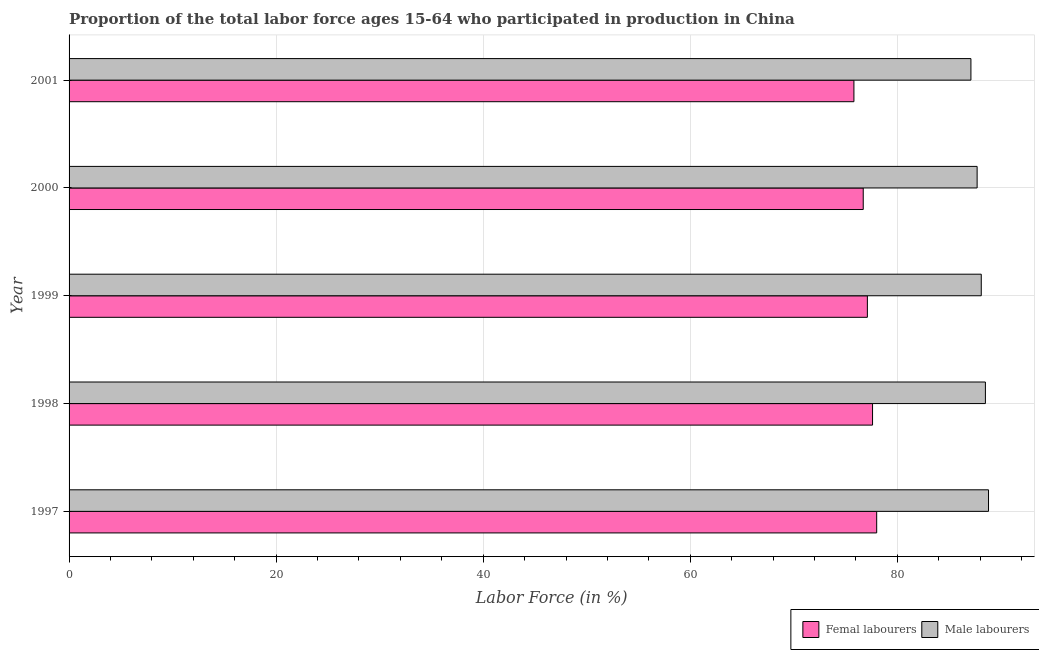How many different coloured bars are there?
Provide a succinct answer. 2. How many bars are there on the 4th tick from the bottom?
Ensure brevity in your answer.  2. What is the label of the 3rd group of bars from the top?
Your answer should be very brief. 1999. What is the percentage of male labour force in 1998?
Your answer should be compact. 88.5. Across all years, what is the maximum percentage of female labor force?
Your answer should be very brief. 78. Across all years, what is the minimum percentage of male labour force?
Your answer should be compact. 87.1. In which year was the percentage of female labor force maximum?
Your answer should be compact. 1997. In which year was the percentage of female labor force minimum?
Give a very brief answer. 2001. What is the total percentage of male labour force in the graph?
Offer a very short reply. 440.2. What is the difference between the percentage of male labour force in 1999 and that in 2000?
Keep it short and to the point. 0.4. What is the difference between the percentage of female labor force in 1999 and the percentage of male labour force in 1997?
Keep it short and to the point. -11.7. What is the average percentage of female labor force per year?
Give a very brief answer. 77.04. In the year 2000, what is the difference between the percentage of male labour force and percentage of female labor force?
Ensure brevity in your answer.  11. In how many years, is the percentage of male labour force greater than 84 %?
Ensure brevity in your answer.  5. What is the ratio of the percentage of female labor force in 1998 to that in 1999?
Provide a short and direct response. 1.01. Is the percentage of female labor force in 1999 less than that in 2001?
Give a very brief answer. No. Is the difference between the percentage of female labor force in 1997 and 1998 greater than the difference between the percentage of male labour force in 1997 and 1998?
Ensure brevity in your answer.  Yes. What is the difference between the highest and the second highest percentage of female labor force?
Provide a succinct answer. 0.4. What is the difference between the highest and the lowest percentage of male labour force?
Offer a very short reply. 1.7. In how many years, is the percentage of female labor force greater than the average percentage of female labor force taken over all years?
Keep it short and to the point. 3. What does the 2nd bar from the top in 1999 represents?
Provide a succinct answer. Femal labourers. What does the 1st bar from the bottom in 1998 represents?
Make the answer very short. Femal labourers. Are all the bars in the graph horizontal?
Offer a very short reply. Yes. Are the values on the major ticks of X-axis written in scientific E-notation?
Offer a very short reply. No. Does the graph contain any zero values?
Ensure brevity in your answer.  No. Where does the legend appear in the graph?
Offer a terse response. Bottom right. How are the legend labels stacked?
Keep it short and to the point. Horizontal. What is the title of the graph?
Ensure brevity in your answer.  Proportion of the total labor force ages 15-64 who participated in production in China. What is the label or title of the Y-axis?
Your answer should be very brief. Year. What is the Labor Force (in %) of Femal labourers in 1997?
Give a very brief answer. 78. What is the Labor Force (in %) of Male labourers in 1997?
Keep it short and to the point. 88.8. What is the Labor Force (in %) in Femal labourers in 1998?
Give a very brief answer. 77.6. What is the Labor Force (in %) in Male labourers in 1998?
Keep it short and to the point. 88.5. What is the Labor Force (in %) in Femal labourers in 1999?
Provide a succinct answer. 77.1. What is the Labor Force (in %) in Male labourers in 1999?
Ensure brevity in your answer.  88.1. What is the Labor Force (in %) of Femal labourers in 2000?
Offer a terse response. 76.7. What is the Labor Force (in %) in Male labourers in 2000?
Offer a very short reply. 87.7. What is the Labor Force (in %) in Femal labourers in 2001?
Ensure brevity in your answer.  75.8. What is the Labor Force (in %) of Male labourers in 2001?
Make the answer very short. 87.1. Across all years, what is the maximum Labor Force (in %) in Male labourers?
Provide a short and direct response. 88.8. Across all years, what is the minimum Labor Force (in %) in Femal labourers?
Your answer should be very brief. 75.8. Across all years, what is the minimum Labor Force (in %) of Male labourers?
Provide a succinct answer. 87.1. What is the total Labor Force (in %) in Femal labourers in the graph?
Your answer should be very brief. 385.2. What is the total Labor Force (in %) of Male labourers in the graph?
Your answer should be compact. 440.2. What is the difference between the Labor Force (in %) in Femal labourers in 1997 and that in 1999?
Provide a short and direct response. 0.9. What is the difference between the Labor Force (in %) in Male labourers in 1997 and that in 2000?
Ensure brevity in your answer.  1.1. What is the difference between the Labor Force (in %) in Femal labourers in 1997 and that in 2001?
Keep it short and to the point. 2.2. What is the difference between the Labor Force (in %) in Femal labourers in 1998 and that in 1999?
Keep it short and to the point. 0.5. What is the difference between the Labor Force (in %) in Male labourers in 1998 and that in 1999?
Offer a terse response. 0.4. What is the difference between the Labor Force (in %) of Femal labourers in 1998 and that in 2000?
Ensure brevity in your answer.  0.9. What is the difference between the Labor Force (in %) in Male labourers in 1998 and that in 2000?
Offer a very short reply. 0.8. What is the difference between the Labor Force (in %) of Male labourers in 1998 and that in 2001?
Keep it short and to the point. 1.4. What is the difference between the Labor Force (in %) of Femal labourers in 1999 and that in 2000?
Your answer should be compact. 0.4. What is the difference between the Labor Force (in %) in Male labourers in 1999 and that in 2000?
Your response must be concise. 0.4. What is the difference between the Labor Force (in %) of Femal labourers in 2000 and that in 2001?
Ensure brevity in your answer.  0.9. What is the difference between the Labor Force (in %) in Femal labourers in 1997 and the Labor Force (in %) in Male labourers in 2000?
Offer a terse response. -9.7. What is the difference between the Labor Force (in %) in Femal labourers in 1998 and the Labor Force (in %) in Male labourers in 1999?
Keep it short and to the point. -10.5. What is the difference between the Labor Force (in %) of Femal labourers in 1998 and the Labor Force (in %) of Male labourers in 2001?
Provide a succinct answer. -9.5. What is the difference between the Labor Force (in %) of Femal labourers in 1999 and the Labor Force (in %) of Male labourers in 2000?
Your answer should be compact. -10.6. What is the difference between the Labor Force (in %) in Femal labourers in 1999 and the Labor Force (in %) in Male labourers in 2001?
Keep it short and to the point. -10. What is the average Labor Force (in %) in Femal labourers per year?
Your answer should be very brief. 77.04. What is the average Labor Force (in %) in Male labourers per year?
Provide a succinct answer. 88.04. In the year 1998, what is the difference between the Labor Force (in %) of Femal labourers and Labor Force (in %) of Male labourers?
Your answer should be compact. -10.9. In the year 2001, what is the difference between the Labor Force (in %) in Femal labourers and Labor Force (in %) in Male labourers?
Provide a short and direct response. -11.3. What is the ratio of the Labor Force (in %) of Male labourers in 1997 to that in 1998?
Offer a terse response. 1. What is the ratio of the Labor Force (in %) of Femal labourers in 1997 to that in 1999?
Your answer should be very brief. 1.01. What is the ratio of the Labor Force (in %) in Male labourers in 1997 to that in 1999?
Your answer should be very brief. 1.01. What is the ratio of the Labor Force (in %) in Femal labourers in 1997 to that in 2000?
Give a very brief answer. 1.02. What is the ratio of the Labor Force (in %) of Male labourers in 1997 to that in 2000?
Keep it short and to the point. 1.01. What is the ratio of the Labor Force (in %) in Femal labourers in 1997 to that in 2001?
Your answer should be very brief. 1.03. What is the ratio of the Labor Force (in %) of Male labourers in 1997 to that in 2001?
Give a very brief answer. 1.02. What is the ratio of the Labor Force (in %) of Femal labourers in 1998 to that in 1999?
Your answer should be very brief. 1.01. What is the ratio of the Labor Force (in %) of Femal labourers in 1998 to that in 2000?
Offer a very short reply. 1.01. What is the ratio of the Labor Force (in %) in Male labourers in 1998 to that in 2000?
Ensure brevity in your answer.  1.01. What is the ratio of the Labor Force (in %) in Femal labourers in 1998 to that in 2001?
Provide a short and direct response. 1.02. What is the ratio of the Labor Force (in %) of Male labourers in 1998 to that in 2001?
Give a very brief answer. 1.02. What is the ratio of the Labor Force (in %) in Femal labourers in 1999 to that in 2000?
Offer a very short reply. 1.01. What is the ratio of the Labor Force (in %) of Male labourers in 1999 to that in 2000?
Provide a short and direct response. 1. What is the ratio of the Labor Force (in %) in Femal labourers in 1999 to that in 2001?
Give a very brief answer. 1.02. What is the ratio of the Labor Force (in %) in Male labourers in 1999 to that in 2001?
Offer a very short reply. 1.01. What is the ratio of the Labor Force (in %) of Femal labourers in 2000 to that in 2001?
Your answer should be compact. 1.01. What is the difference between the highest and the second highest Labor Force (in %) of Male labourers?
Make the answer very short. 0.3. 